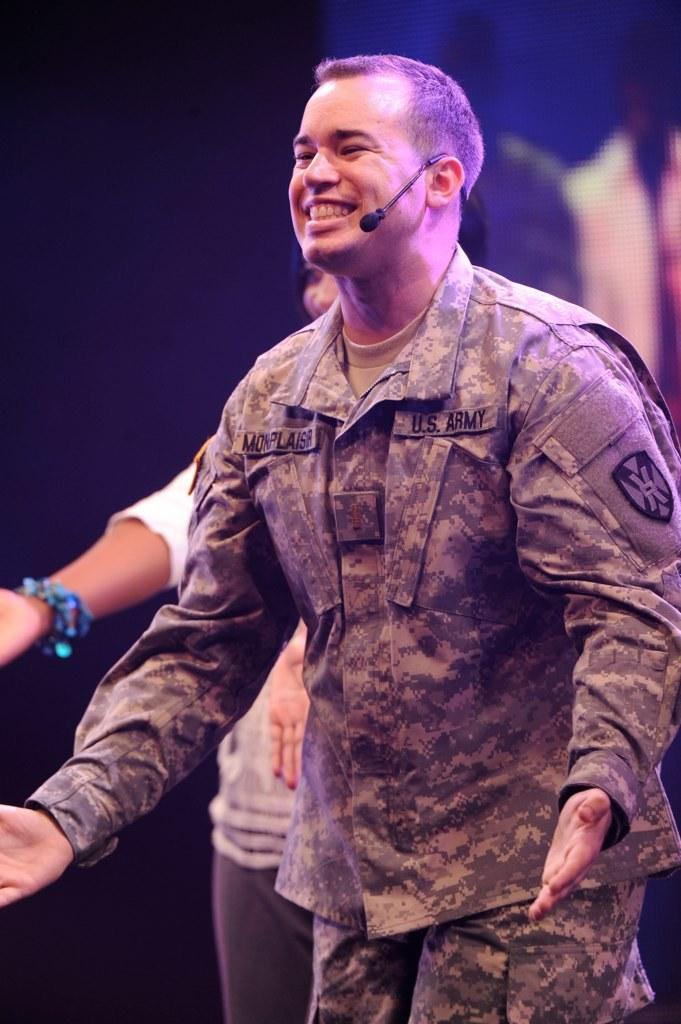What is the main subject of the image? The main subject of the image is a man. What is the man wearing in the image? The man is wearing a microphone in the image. What expression does the man have in the image? The man is smiling in the image. Can you describe the background of the image? The background of the image is blurry, and there is a person visible in the background. What type of bell can be heard ringing in the image? There is no bell present or ringing in the image. Can you see the man's veins through his skin in the image? The image does not provide enough detail to see the man's veins through his skin. What type of plough is being used in the image? There is no plough present in the image. 